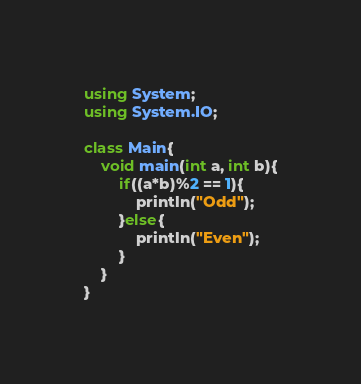Convert code to text. <code><loc_0><loc_0><loc_500><loc_500><_C#_>using System;
using System.IO;

class Main{
    void main(int a, int b){
        if((a*b)%2 == 1){
            println("Odd");
        }else{
            println("Even");
        }
    }
}</code> 